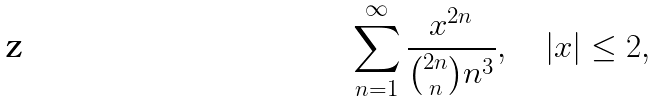Convert formula to latex. <formula><loc_0><loc_0><loc_500><loc_500>\sum _ { n = 1 } ^ { \infty } \frac { x ^ { 2 n } } { { 2 n \choose n } n ^ { 3 } } , \quad | x | \leq 2 ,</formula> 